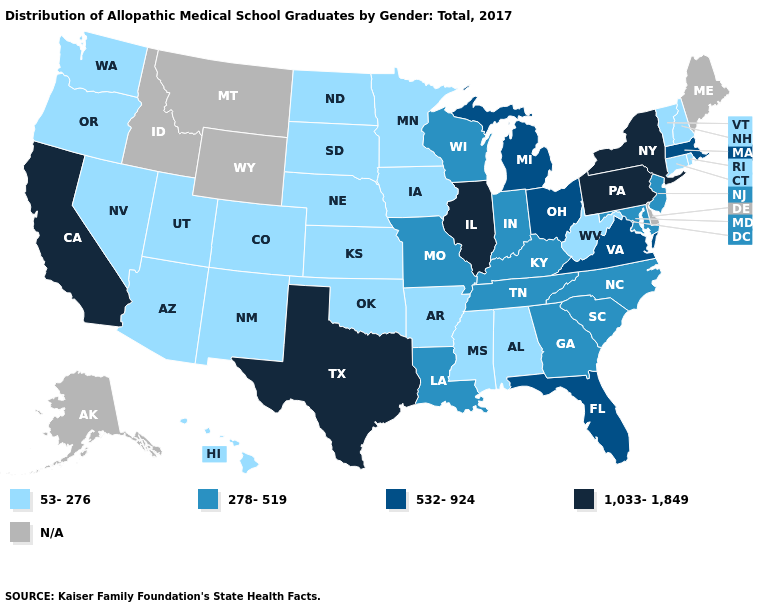What is the value of Alaska?
Give a very brief answer. N/A. What is the value of Wisconsin?
Keep it brief. 278-519. Which states hav the highest value in the Northeast?
Keep it brief. New York, Pennsylvania. What is the highest value in the USA?
Keep it brief. 1,033-1,849. What is the value of Delaware?
Be succinct. N/A. Name the states that have a value in the range 278-519?
Write a very short answer. Georgia, Indiana, Kentucky, Louisiana, Maryland, Missouri, New Jersey, North Carolina, South Carolina, Tennessee, Wisconsin. What is the value of New Mexico?
Short answer required. 53-276. How many symbols are there in the legend?
Quick response, please. 5. What is the value of Vermont?
Keep it brief. 53-276. What is the value of South Dakota?
Give a very brief answer. 53-276. Name the states that have a value in the range N/A?
Write a very short answer. Alaska, Delaware, Idaho, Maine, Montana, Wyoming. What is the value of South Carolina?
Be succinct. 278-519. Does Massachusetts have the lowest value in the Northeast?
Be succinct. No. Name the states that have a value in the range N/A?
Short answer required. Alaska, Delaware, Idaho, Maine, Montana, Wyoming. What is the value of Georgia?
Write a very short answer. 278-519. 